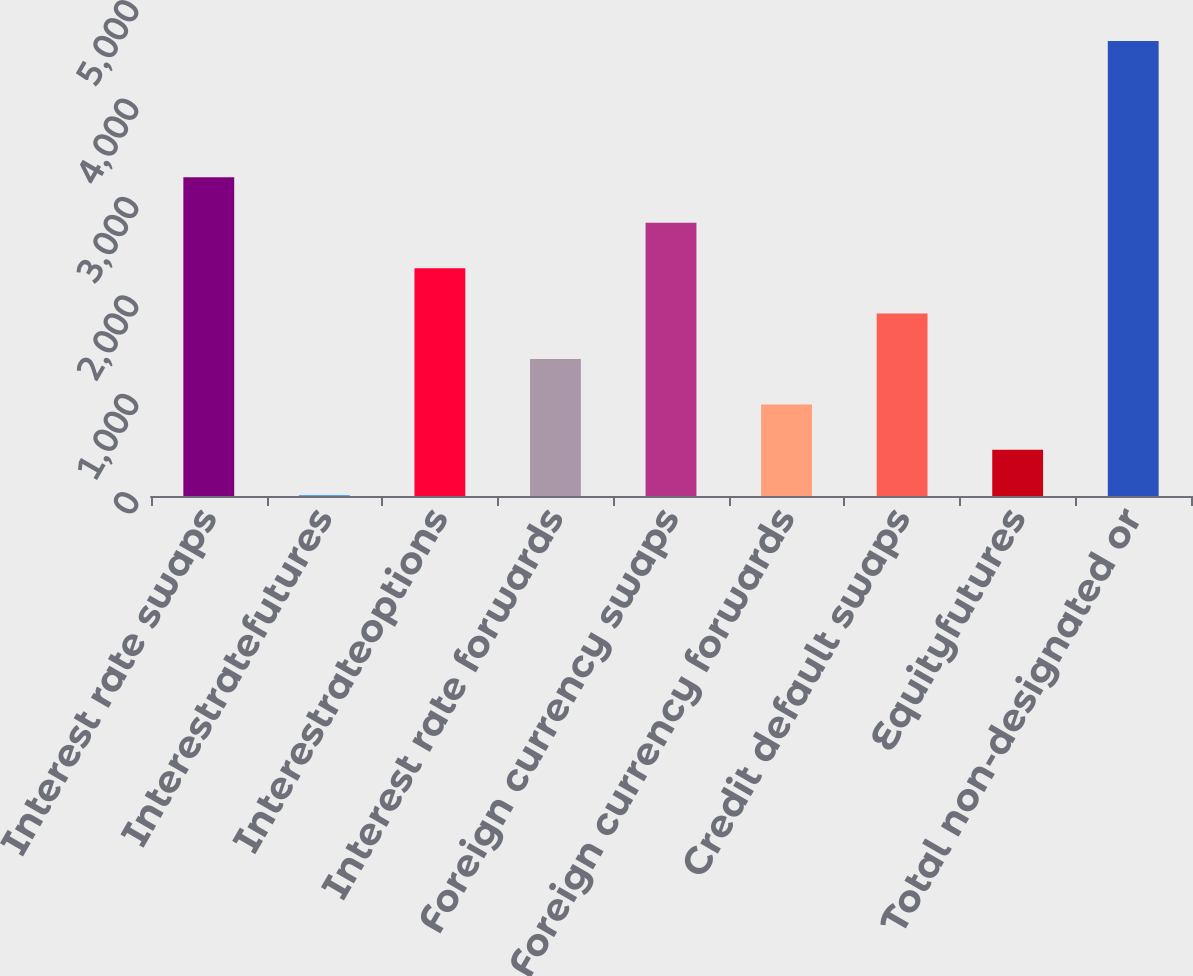Convert chart to OTSL. <chart><loc_0><loc_0><loc_500><loc_500><bar_chart><fcel>Interest rate swaps<fcel>Interestratefutures<fcel>Interestrateoptions<fcel>Interest rate forwards<fcel>Foreign currency swaps<fcel>Foreign currency forwards<fcel>Credit default swaps<fcel>Equityfutures<fcel>Total non-designated or<nl><fcel>3238.5<fcel>8<fcel>2315.5<fcel>1392.5<fcel>2777<fcel>931<fcel>1854<fcel>469.5<fcel>4623<nl></chart> 